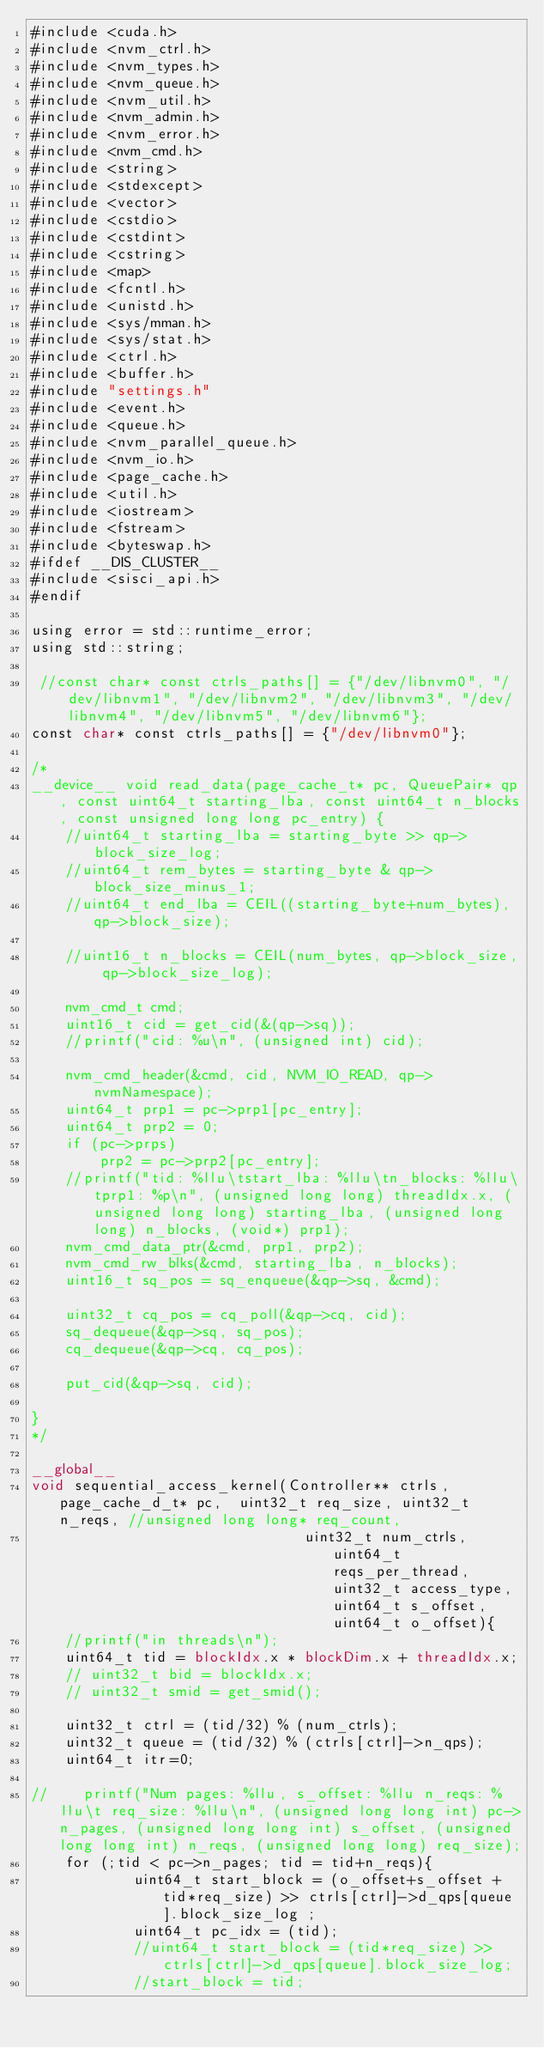<code> <loc_0><loc_0><loc_500><loc_500><_Cuda_>#include <cuda.h>
#include <nvm_ctrl.h>
#include <nvm_types.h>
#include <nvm_queue.h>
#include <nvm_util.h>
#include <nvm_admin.h>
#include <nvm_error.h>
#include <nvm_cmd.h>
#include <string>
#include <stdexcept>
#include <vector>
#include <cstdio>
#include <cstdint>
#include <cstring>
#include <map>
#include <fcntl.h>
#include <unistd.h>
#include <sys/mman.h>
#include <sys/stat.h>
#include <ctrl.h>
#include <buffer.h>
#include "settings.h"
#include <event.h>
#include <queue.h>
#include <nvm_parallel_queue.h>
#include <nvm_io.h>
#include <page_cache.h>
#include <util.h>
#include <iostream>
#include <fstream>
#include <byteswap.h>
#ifdef __DIS_CLUSTER__
#include <sisci_api.h>
#endif

using error = std::runtime_error;
using std::string;

 //const char* const ctrls_paths[] = {"/dev/libnvm0", "/dev/libnvm1", "/dev/libnvm2", "/dev/libnvm3", "/dev/libnvm4", "/dev/libnvm5", "/dev/libnvm6"};
const char* const ctrls_paths[] = {"/dev/libnvm0"};

/*
__device__ void read_data(page_cache_t* pc, QueuePair* qp, const uint64_t starting_lba, const uint64_t n_blocks, const unsigned long long pc_entry) {
    //uint64_t starting_lba = starting_byte >> qp->block_size_log;
    //uint64_t rem_bytes = starting_byte & qp->block_size_minus_1;
    //uint64_t end_lba = CEIL((starting_byte+num_bytes), qp->block_size);

    //uint16_t n_blocks = CEIL(num_bytes, qp->block_size, qp->block_size_log);
 
    nvm_cmd_t cmd;
    uint16_t cid = get_cid(&(qp->sq));
    //printf("cid: %u\n", (unsigned int) cid);
 
    nvm_cmd_header(&cmd, cid, NVM_IO_READ, qp->nvmNamespace);
    uint64_t prp1 = pc->prp1[pc_entry];
    uint64_t prp2 = 0;
    if (pc->prps)
        prp2 = pc->prp2[pc_entry];
    //printf("tid: %llu\tstart_lba: %llu\tn_blocks: %llu\tprp1: %p\n", (unsigned long long) threadIdx.x, (unsigned long long) starting_lba, (unsigned long long) n_blocks, (void*) prp1);
    nvm_cmd_data_ptr(&cmd, prp1, prp2);
    nvm_cmd_rw_blks(&cmd, starting_lba, n_blocks);
    uint16_t sq_pos = sq_enqueue(&qp->sq, &cmd);

    uint32_t cq_pos = cq_poll(&qp->cq, cid);
    sq_dequeue(&qp->sq, sq_pos);
    cq_dequeue(&qp->cq, cq_pos);
 
    put_cid(&qp->sq, cid);
 
}
*/

__global__
void sequential_access_kernel(Controller** ctrls, page_cache_d_t* pc,  uint32_t req_size, uint32_t n_reqs, //unsigned long long* req_count,
                                uint32_t num_ctrls, uint64_t reqs_per_thread, uint32_t access_type, uint64_t s_offset, uint64_t o_offset){
    //printf("in threads\n");
    uint64_t tid = blockIdx.x * blockDim.x + threadIdx.x;
    // uint32_t bid = blockIdx.x;
    // uint32_t smid = get_smid();

    uint32_t ctrl = (tid/32) % (num_ctrls);
    uint32_t queue = (tid/32) % (ctrls[ctrl]->n_qps);
    uint64_t itr=0; 

//    printf("Num pages: %llu, s_offset: %llu n_reqs: %llu\t req_size: %llu\n", (unsigned long long int) pc->n_pages, (unsigned long long int) s_offset, (unsigned long long int) n_reqs, (unsigned long long) req_size); 
    for (;tid < pc->n_pages; tid = tid+n_reqs){
            uint64_t start_block = (o_offset+s_offset + tid*req_size) >> ctrls[ctrl]->d_qps[queue].block_size_log ;
            uint64_t pc_idx = (tid);
            //uint64_t start_block = (tid*req_size) >> ctrls[ctrl]->d_qps[queue].block_size_log;
            //start_block = tid;</code> 